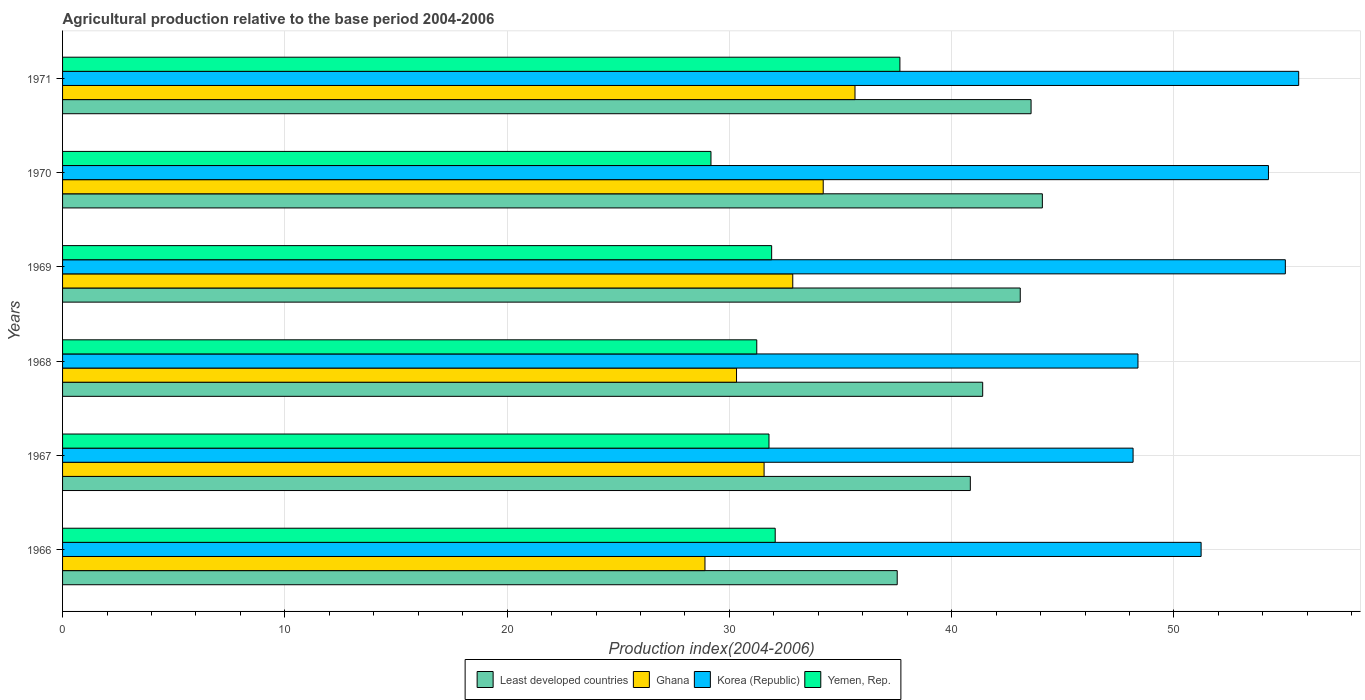How many different coloured bars are there?
Give a very brief answer. 4. Are the number of bars on each tick of the Y-axis equal?
Offer a terse response. Yes. How many bars are there on the 6th tick from the top?
Give a very brief answer. 4. What is the label of the 5th group of bars from the top?
Your response must be concise. 1967. In how many cases, is the number of bars for a given year not equal to the number of legend labels?
Your answer should be very brief. 0. What is the agricultural production index in Ghana in 1971?
Your answer should be compact. 35.65. Across all years, what is the maximum agricultural production index in Least developed countries?
Provide a short and direct response. 44.08. Across all years, what is the minimum agricultural production index in Ghana?
Keep it short and to the point. 28.9. In which year was the agricultural production index in Ghana minimum?
Provide a succinct answer. 1966. What is the total agricultural production index in Korea (Republic) in the graph?
Give a very brief answer. 312.63. What is the difference between the agricultural production index in Least developed countries in 1968 and that in 1971?
Offer a very short reply. -2.18. What is the difference between the agricultural production index in Ghana in 1971 and the agricultural production index in Korea (Republic) in 1968?
Your response must be concise. -12.73. What is the average agricultural production index in Korea (Republic) per year?
Provide a succinct answer. 52.1. In the year 1970, what is the difference between the agricultural production index in Yemen, Rep. and agricultural production index in Korea (Republic)?
Provide a short and direct response. -25.08. In how many years, is the agricultural production index in Korea (Republic) greater than 18 ?
Your answer should be very brief. 6. What is the ratio of the agricultural production index in Korea (Republic) in 1968 to that in 1970?
Provide a short and direct response. 0.89. Is the agricultural production index in Korea (Republic) in 1967 less than that in 1970?
Your answer should be compact. Yes. Is the difference between the agricultural production index in Yemen, Rep. in 1966 and 1970 greater than the difference between the agricultural production index in Korea (Republic) in 1966 and 1970?
Provide a short and direct response. Yes. What is the difference between the highest and the second highest agricultural production index in Yemen, Rep.?
Your answer should be very brief. 5.61. What is the difference between the highest and the lowest agricultural production index in Least developed countries?
Your answer should be very brief. 6.53. In how many years, is the agricultural production index in Korea (Republic) greater than the average agricultural production index in Korea (Republic) taken over all years?
Give a very brief answer. 3. Is it the case that in every year, the sum of the agricultural production index in Least developed countries and agricultural production index in Yemen, Rep. is greater than the agricultural production index in Korea (Republic)?
Make the answer very short. Yes. Are the values on the major ticks of X-axis written in scientific E-notation?
Offer a very short reply. No. Does the graph contain any zero values?
Ensure brevity in your answer.  No. Does the graph contain grids?
Make the answer very short. Yes. Where does the legend appear in the graph?
Offer a very short reply. Bottom center. How many legend labels are there?
Provide a short and direct response. 4. How are the legend labels stacked?
Your response must be concise. Horizontal. What is the title of the graph?
Your response must be concise. Agricultural production relative to the base period 2004-2006. What is the label or title of the X-axis?
Your response must be concise. Production index(2004-2006). What is the Production index(2004-2006) in Least developed countries in 1966?
Keep it short and to the point. 37.55. What is the Production index(2004-2006) in Ghana in 1966?
Offer a very short reply. 28.9. What is the Production index(2004-2006) in Korea (Republic) in 1966?
Make the answer very short. 51.22. What is the Production index(2004-2006) of Yemen, Rep. in 1966?
Provide a succinct answer. 32.06. What is the Production index(2004-2006) in Least developed countries in 1967?
Make the answer very short. 40.84. What is the Production index(2004-2006) in Ghana in 1967?
Give a very brief answer. 31.56. What is the Production index(2004-2006) in Korea (Republic) in 1967?
Offer a very short reply. 48.16. What is the Production index(2004-2006) in Yemen, Rep. in 1967?
Give a very brief answer. 31.78. What is the Production index(2004-2006) of Least developed countries in 1968?
Give a very brief answer. 41.39. What is the Production index(2004-2006) of Ghana in 1968?
Your answer should be very brief. 30.32. What is the Production index(2004-2006) of Korea (Republic) in 1968?
Your answer should be very brief. 48.38. What is the Production index(2004-2006) in Yemen, Rep. in 1968?
Provide a short and direct response. 31.23. What is the Production index(2004-2006) of Least developed countries in 1969?
Offer a terse response. 43.08. What is the Production index(2004-2006) of Ghana in 1969?
Provide a succinct answer. 32.85. What is the Production index(2004-2006) of Korea (Republic) in 1969?
Make the answer very short. 55.01. What is the Production index(2004-2006) of Yemen, Rep. in 1969?
Provide a short and direct response. 31.9. What is the Production index(2004-2006) of Least developed countries in 1970?
Offer a very short reply. 44.08. What is the Production index(2004-2006) of Ghana in 1970?
Provide a succinct answer. 34.22. What is the Production index(2004-2006) in Korea (Republic) in 1970?
Ensure brevity in your answer.  54.25. What is the Production index(2004-2006) in Yemen, Rep. in 1970?
Your answer should be very brief. 29.17. What is the Production index(2004-2006) of Least developed countries in 1971?
Make the answer very short. 43.57. What is the Production index(2004-2006) of Ghana in 1971?
Provide a short and direct response. 35.65. What is the Production index(2004-2006) in Korea (Republic) in 1971?
Ensure brevity in your answer.  55.61. What is the Production index(2004-2006) in Yemen, Rep. in 1971?
Keep it short and to the point. 37.67. Across all years, what is the maximum Production index(2004-2006) in Least developed countries?
Your response must be concise. 44.08. Across all years, what is the maximum Production index(2004-2006) of Ghana?
Offer a very short reply. 35.65. Across all years, what is the maximum Production index(2004-2006) in Korea (Republic)?
Give a very brief answer. 55.61. Across all years, what is the maximum Production index(2004-2006) of Yemen, Rep.?
Your answer should be very brief. 37.67. Across all years, what is the minimum Production index(2004-2006) in Least developed countries?
Make the answer very short. 37.55. Across all years, what is the minimum Production index(2004-2006) of Ghana?
Make the answer very short. 28.9. Across all years, what is the minimum Production index(2004-2006) of Korea (Republic)?
Your answer should be very brief. 48.16. Across all years, what is the minimum Production index(2004-2006) of Yemen, Rep.?
Offer a very short reply. 29.17. What is the total Production index(2004-2006) of Least developed countries in the graph?
Provide a short and direct response. 250.51. What is the total Production index(2004-2006) in Ghana in the graph?
Your response must be concise. 193.5. What is the total Production index(2004-2006) in Korea (Republic) in the graph?
Your answer should be very brief. 312.63. What is the total Production index(2004-2006) in Yemen, Rep. in the graph?
Offer a terse response. 193.81. What is the difference between the Production index(2004-2006) in Least developed countries in 1966 and that in 1967?
Give a very brief answer. -3.29. What is the difference between the Production index(2004-2006) in Ghana in 1966 and that in 1967?
Keep it short and to the point. -2.66. What is the difference between the Production index(2004-2006) in Korea (Republic) in 1966 and that in 1967?
Ensure brevity in your answer.  3.06. What is the difference between the Production index(2004-2006) in Yemen, Rep. in 1966 and that in 1967?
Provide a short and direct response. 0.28. What is the difference between the Production index(2004-2006) in Least developed countries in 1966 and that in 1968?
Give a very brief answer. -3.85. What is the difference between the Production index(2004-2006) in Ghana in 1966 and that in 1968?
Ensure brevity in your answer.  -1.42. What is the difference between the Production index(2004-2006) of Korea (Republic) in 1966 and that in 1968?
Provide a short and direct response. 2.84. What is the difference between the Production index(2004-2006) of Yemen, Rep. in 1966 and that in 1968?
Your answer should be very brief. 0.83. What is the difference between the Production index(2004-2006) in Least developed countries in 1966 and that in 1969?
Keep it short and to the point. -5.53. What is the difference between the Production index(2004-2006) of Ghana in 1966 and that in 1969?
Your response must be concise. -3.95. What is the difference between the Production index(2004-2006) in Korea (Republic) in 1966 and that in 1969?
Offer a very short reply. -3.79. What is the difference between the Production index(2004-2006) of Yemen, Rep. in 1966 and that in 1969?
Make the answer very short. 0.16. What is the difference between the Production index(2004-2006) in Least developed countries in 1966 and that in 1970?
Ensure brevity in your answer.  -6.53. What is the difference between the Production index(2004-2006) of Ghana in 1966 and that in 1970?
Ensure brevity in your answer.  -5.32. What is the difference between the Production index(2004-2006) in Korea (Republic) in 1966 and that in 1970?
Your response must be concise. -3.03. What is the difference between the Production index(2004-2006) of Yemen, Rep. in 1966 and that in 1970?
Your answer should be compact. 2.89. What is the difference between the Production index(2004-2006) in Least developed countries in 1966 and that in 1971?
Provide a short and direct response. -6.02. What is the difference between the Production index(2004-2006) of Ghana in 1966 and that in 1971?
Give a very brief answer. -6.75. What is the difference between the Production index(2004-2006) of Korea (Republic) in 1966 and that in 1971?
Make the answer very short. -4.39. What is the difference between the Production index(2004-2006) of Yemen, Rep. in 1966 and that in 1971?
Offer a very short reply. -5.61. What is the difference between the Production index(2004-2006) of Least developed countries in 1967 and that in 1968?
Give a very brief answer. -0.56. What is the difference between the Production index(2004-2006) in Ghana in 1967 and that in 1968?
Your answer should be compact. 1.24. What is the difference between the Production index(2004-2006) in Korea (Republic) in 1967 and that in 1968?
Offer a terse response. -0.22. What is the difference between the Production index(2004-2006) in Yemen, Rep. in 1967 and that in 1968?
Provide a succinct answer. 0.55. What is the difference between the Production index(2004-2006) in Least developed countries in 1967 and that in 1969?
Make the answer very short. -2.25. What is the difference between the Production index(2004-2006) of Ghana in 1967 and that in 1969?
Offer a very short reply. -1.29. What is the difference between the Production index(2004-2006) in Korea (Republic) in 1967 and that in 1969?
Make the answer very short. -6.85. What is the difference between the Production index(2004-2006) of Yemen, Rep. in 1967 and that in 1969?
Give a very brief answer. -0.12. What is the difference between the Production index(2004-2006) of Least developed countries in 1967 and that in 1970?
Make the answer very short. -3.24. What is the difference between the Production index(2004-2006) in Ghana in 1967 and that in 1970?
Your answer should be compact. -2.66. What is the difference between the Production index(2004-2006) of Korea (Republic) in 1967 and that in 1970?
Ensure brevity in your answer.  -6.09. What is the difference between the Production index(2004-2006) of Yemen, Rep. in 1967 and that in 1970?
Offer a terse response. 2.61. What is the difference between the Production index(2004-2006) in Least developed countries in 1967 and that in 1971?
Provide a short and direct response. -2.73. What is the difference between the Production index(2004-2006) in Ghana in 1967 and that in 1971?
Your answer should be compact. -4.09. What is the difference between the Production index(2004-2006) in Korea (Republic) in 1967 and that in 1971?
Give a very brief answer. -7.45. What is the difference between the Production index(2004-2006) of Yemen, Rep. in 1967 and that in 1971?
Make the answer very short. -5.89. What is the difference between the Production index(2004-2006) of Least developed countries in 1968 and that in 1969?
Give a very brief answer. -1.69. What is the difference between the Production index(2004-2006) of Ghana in 1968 and that in 1969?
Keep it short and to the point. -2.53. What is the difference between the Production index(2004-2006) in Korea (Republic) in 1968 and that in 1969?
Your answer should be compact. -6.63. What is the difference between the Production index(2004-2006) in Yemen, Rep. in 1968 and that in 1969?
Provide a succinct answer. -0.67. What is the difference between the Production index(2004-2006) in Least developed countries in 1968 and that in 1970?
Give a very brief answer. -2.68. What is the difference between the Production index(2004-2006) in Korea (Republic) in 1968 and that in 1970?
Provide a short and direct response. -5.87. What is the difference between the Production index(2004-2006) in Yemen, Rep. in 1968 and that in 1970?
Keep it short and to the point. 2.06. What is the difference between the Production index(2004-2006) of Least developed countries in 1968 and that in 1971?
Keep it short and to the point. -2.18. What is the difference between the Production index(2004-2006) in Ghana in 1968 and that in 1971?
Provide a short and direct response. -5.33. What is the difference between the Production index(2004-2006) in Korea (Republic) in 1968 and that in 1971?
Your answer should be compact. -7.23. What is the difference between the Production index(2004-2006) of Yemen, Rep. in 1968 and that in 1971?
Your answer should be compact. -6.44. What is the difference between the Production index(2004-2006) of Least developed countries in 1969 and that in 1970?
Offer a terse response. -0.99. What is the difference between the Production index(2004-2006) of Ghana in 1969 and that in 1970?
Keep it short and to the point. -1.37. What is the difference between the Production index(2004-2006) in Korea (Republic) in 1969 and that in 1970?
Provide a succinct answer. 0.76. What is the difference between the Production index(2004-2006) of Yemen, Rep. in 1969 and that in 1970?
Ensure brevity in your answer.  2.73. What is the difference between the Production index(2004-2006) of Least developed countries in 1969 and that in 1971?
Offer a very short reply. -0.49. What is the difference between the Production index(2004-2006) in Yemen, Rep. in 1969 and that in 1971?
Offer a very short reply. -5.77. What is the difference between the Production index(2004-2006) in Least developed countries in 1970 and that in 1971?
Your answer should be compact. 0.51. What is the difference between the Production index(2004-2006) in Ghana in 1970 and that in 1971?
Offer a very short reply. -1.43. What is the difference between the Production index(2004-2006) in Korea (Republic) in 1970 and that in 1971?
Offer a terse response. -1.36. What is the difference between the Production index(2004-2006) in Least developed countries in 1966 and the Production index(2004-2006) in Ghana in 1967?
Offer a very short reply. 5.99. What is the difference between the Production index(2004-2006) in Least developed countries in 1966 and the Production index(2004-2006) in Korea (Republic) in 1967?
Keep it short and to the point. -10.61. What is the difference between the Production index(2004-2006) in Least developed countries in 1966 and the Production index(2004-2006) in Yemen, Rep. in 1967?
Make the answer very short. 5.77. What is the difference between the Production index(2004-2006) of Ghana in 1966 and the Production index(2004-2006) of Korea (Republic) in 1967?
Give a very brief answer. -19.26. What is the difference between the Production index(2004-2006) of Ghana in 1966 and the Production index(2004-2006) of Yemen, Rep. in 1967?
Offer a terse response. -2.88. What is the difference between the Production index(2004-2006) in Korea (Republic) in 1966 and the Production index(2004-2006) in Yemen, Rep. in 1967?
Your answer should be very brief. 19.44. What is the difference between the Production index(2004-2006) of Least developed countries in 1966 and the Production index(2004-2006) of Ghana in 1968?
Offer a very short reply. 7.23. What is the difference between the Production index(2004-2006) of Least developed countries in 1966 and the Production index(2004-2006) of Korea (Republic) in 1968?
Offer a very short reply. -10.83. What is the difference between the Production index(2004-2006) of Least developed countries in 1966 and the Production index(2004-2006) of Yemen, Rep. in 1968?
Ensure brevity in your answer.  6.32. What is the difference between the Production index(2004-2006) in Ghana in 1966 and the Production index(2004-2006) in Korea (Republic) in 1968?
Offer a terse response. -19.48. What is the difference between the Production index(2004-2006) of Ghana in 1966 and the Production index(2004-2006) of Yemen, Rep. in 1968?
Give a very brief answer. -2.33. What is the difference between the Production index(2004-2006) in Korea (Republic) in 1966 and the Production index(2004-2006) in Yemen, Rep. in 1968?
Provide a short and direct response. 19.99. What is the difference between the Production index(2004-2006) of Least developed countries in 1966 and the Production index(2004-2006) of Ghana in 1969?
Your response must be concise. 4.7. What is the difference between the Production index(2004-2006) in Least developed countries in 1966 and the Production index(2004-2006) in Korea (Republic) in 1969?
Keep it short and to the point. -17.46. What is the difference between the Production index(2004-2006) of Least developed countries in 1966 and the Production index(2004-2006) of Yemen, Rep. in 1969?
Your answer should be compact. 5.65. What is the difference between the Production index(2004-2006) in Ghana in 1966 and the Production index(2004-2006) in Korea (Republic) in 1969?
Keep it short and to the point. -26.11. What is the difference between the Production index(2004-2006) of Korea (Republic) in 1966 and the Production index(2004-2006) of Yemen, Rep. in 1969?
Ensure brevity in your answer.  19.32. What is the difference between the Production index(2004-2006) of Least developed countries in 1966 and the Production index(2004-2006) of Ghana in 1970?
Provide a short and direct response. 3.33. What is the difference between the Production index(2004-2006) of Least developed countries in 1966 and the Production index(2004-2006) of Korea (Republic) in 1970?
Ensure brevity in your answer.  -16.7. What is the difference between the Production index(2004-2006) in Least developed countries in 1966 and the Production index(2004-2006) in Yemen, Rep. in 1970?
Provide a succinct answer. 8.38. What is the difference between the Production index(2004-2006) in Ghana in 1966 and the Production index(2004-2006) in Korea (Republic) in 1970?
Ensure brevity in your answer.  -25.35. What is the difference between the Production index(2004-2006) of Ghana in 1966 and the Production index(2004-2006) of Yemen, Rep. in 1970?
Ensure brevity in your answer.  -0.27. What is the difference between the Production index(2004-2006) of Korea (Republic) in 1966 and the Production index(2004-2006) of Yemen, Rep. in 1970?
Ensure brevity in your answer.  22.05. What is the difference between the Production index(2004-2006) in Least developed countries in 1966 and the Production index(2004-2006) in Ghana in 1971?
Make the answer very short. 1.9. What is the difference between the Production index(2004-2006) of Least developed countries in 1966 and the Production index(2004-2006) of Korea (Republic) in 1971?
Your answer should be very brief. -18.06. What is the difference between the Production index(2004-2006) in Least developed countries in 1966 and the Production index(2004-2006) in Yemen, Rep. in 1971?
Make the answer very short. -0.12. What is the difference between the Production index(2004-2006) of Ghana in 1966 and the Production index(2004-2006) of Korea (Republic) in 1971?
Make the answer very short. -26.71. What is the difference between the Production index(2004-2006) in Ghana in 1966 and the Production index(2004-2006) in Yemen, Rep. in 1971?
Provide a succinct answer. -8.77. What is the difference between the Production index(2004-2006) of Korea (Republic) in 1966 and the Production index(2004-2006) of Yemen, Rep. in 1971?
Provide a short and direct response. 13.55. What is the difference between the Production index(2004-2006) in Least developed countries in 1967 and the Production index(2004-2006) in Ghana in 1968?
Ensure brevity in your answer.  10.52. What is the difference between the Production index(2004-2006) of Least developed countries in 1967 and the Production index(2004-2006) of Korea (Republic) in 1968?
Give a very brief answer. -7.54. What is the difference between the Production index(2004-2006) in Least developed countries in 1967 and the Production index(2004-2006) in Yemen, Rep. in 1968?
Keep it short and to the point. 9.61. What is the difference between the Production index(2004-2006) in Ghana in 1967 and the Production index(2004-2006) in Korea (Republic) in 1968?
Offer a terse response. -16.82. What is the difference between the Production index(2004-2006) of Ghana in 1967 and the Production index(2004-2006) of Yemen, Rep. in 1968?
Ensure brevity in your answer.  0.33. What is the difference between the Production index(2004-2006) of Korea (Republic) in 1967 and the Production index(2004-2006) of Yemen, Rep. in 1968?
Your response must be concise. 16.93. What is the difference between the Production index(2004-2006) of Least developed countries in 1967 and the Production index(2004-2006) of Ghana in 1969?
Ensure brevity in your answer.  7.99. What is the difference between the Production index(2004-2006) in Least developed countries in 1967 and the Production index(2004-2006) in Korea (Republic) in 1969?
Provide a short and direct response. -14.17. What is the difference between the Production index(2004-2006) of Least developed countries in 1967 and the Production index(2004-2006) of Yemen, Rep. in 1969?
Provide a short and direct response. 8.94. What is the difference between the Production index(2004-2006) in Ghana in 1967 and the Production index(2004-2006) in Korea (Republic) in 1969?
Offer a terse response. -23.45. What is the difference between the Production index(2004-2006) of Ghana in 1967 and the Production index(2004-2006) of Yemen, Rep. in 1969?
Your response must be concise. -0.34. What is the difference between the Production index(2004-2006) of Korea (Republic) in 1967 and the Production index(2004-2006) of Yemen, Rep. in 1969?
Provide a short and direct response. 16.26. What is the difference between the Production index(2004-2006) of Least developed countries in 1967 and the Production index(2004-2006) of Ghana in 1970?
Ensure brevity in your answer.  6.62. What is the difference between the Production index(2004-2006) in Least developed countries in 1967 and the Production index(2004-2006) in Korea (Republic) in 1970?
Your response must be concise. -13.41. What is the difference between the Production index(2004-2006) of Least developed countries in 1967 and the Production index(2004-2006) of Yemen, Rep. in 1970?
Make the answer very short. 11.67. What is the difference between the Production index(2004-2006) in Ghana in 1967 and the Production index(2004-2006) in Korea (Republic) in 1970?
Ensure brevity in your answer.  -22.69. What is the difference between the Production index(2004-2006) of Ghana in 1967 and the Production index(2004-2006) of Yemen, Rep. in 1970?
Your response must be concise. 2.39. What is the difference between the Production index(2004-2006) of Korea (Republic) in 1967 and the Production index(2004-2006) of Yemen, Rep. in 1970?
Your response must be concise. 18.99. What is the difference between the Production index(2004-2006) in Least developed countries in 1967 and the Production index(2004-2006) in Ghana in 1971?
Your answer should be very brief. 5.19. What is the difference between the Production index(2004-2006) of Least developed countries in 1967 and the Production index(2004-2006) of Korea (Republic) in 1971?
Your response must be concise. -14.77. What is the difference between the Production index(2004-2006) of Least developed countries in 1967 and the Production index(2004-2006) of Yemen, Rep. in 1971?
Your response must be concise. 3.17. What is the difference between the Production index(2004-2006) of Ghana in 1967 and the Production index(2004-2006) of Korea (Republic) in 1971?
Offer a very short reply. -24.05. What is the difference between the Production index(2004-2006) of Ghana in 1967 and the Production index(2004-2006) of Yemen, Rep. in 1971?
Offer a very short reply. -6.11. What is the difference between the Production index(2004-2006) in Korea (Republic) in 1967 and the Production index(2004-2006) in Yemen, Rep. in 1971?
Offer a very short reply. 10.49. What is the difference between the Production index(2004-2006) in Least developed countries in 1968 and the Production index(2004-2006) in Ghana in 1969?
Give a very brief answer. 8.54. What is the difference between the Production index(2004-2006) in Least developed countries in 1968 and the Production index(2004-2006) in Korea (Republic) in 1969?
Your answer should be compact. -13.62. What is the difference between the Production index(2004-2006) of Least developed countries in 1968 and the Production index(2004-2006) of Yemen, Rep. in 1969?
Make the answer very short. 9.49. What is the difference between the Production index(2004-2006) in Ghana in 1968 and the Production index(2004-2006) in Korea (Republic) in 1969?
Keep it short and to the point. -24.69. What is the difference between the Production index(2004-2006) of Ghana in 1968 and the Production index(2004-2006) of Yemen, Rep. in 1969?
Give a very brief answer. -1.58. What is the difference between the Production index(2004-2006) in Korea (Republic) in 1968 and the Production index(2004-2006) in Yemen, Rep. in 1969?
Offer a very short reply. 16.48. What is the difference between the Production index(2004-2006) of Least developed countries in 1968 and the Production index(2004-2006) of Ghana in 1970?
Ensure brevity in your answer.  7.17. What is the difference between the Production index(2004-2006) of Least developed countries in 1968 and the Production index(2004-2006) of Korea (Republic) in 1970?
Provide a succinct answer. -12.86. What is the difference between the Production index(2004-2006) of Least developed countries in 1968 and the Production index(2004-2006) of Yemen, Rep. in 1970?
Your answer should be compact. 12.22. What is the difference between the Production index(2004-2006) of Ghana in 1968 and the Production index(2004-2006) of Korea (Republic) in 1970?
Make the answer very short. -23.93. What is the difference between the Production index(2004-2006) of Ghana in 1968 and the Production index(2004-2006) of Yemen, Rep. in 1970?
Make the answer very short. 1.15. What is the difference between the Production index(2004-2006) in Korea (Republic) in 1968 and the Production index(2004-2006) in Yemen, Rep. in 1970?
Make the answer very short. 19.21. What is the difference between the Production index(2004-2006) in Least developed countries in 1968 and the Production index(2004-2006) in Ghana in 1971?
Ensure brevity in your answer.  5.74. What is the difference between the Production index(2004-2006) in Least developed countries in 1968 and the Production index(2004-2006) in Korea (Republic) in 1971?
Your answer should be very brief. -14.22. What is the difference between the Production index(2004-2006) in Least developed countries in 1968 and the Production index(2004-2006) in Yemen, Rep. in 1971?
Offer a terse response. 3.72. What is the difference between the Production index(2004-2006) of Ghana in 1968 and the Production index(2004-2006) of Korea (Republic) in 1971?
Give a very brief answer. -25.29. What is the difference between the Production index(2004-2006) of Ghana in 1968 and the Production index(2004-2006) of Yemen, Rep. in 1971?
Offer a very short reply. -7.35. What is the difference between the Production index(2004-2006) of Korea (Republic) in 1968 and the Production index(2004-2006) of Yemen, Rep. in 1971?
Your response must be concise. 10.71. What is the difference between the Production index(2004-2006) in Least developed countries in 1969 and the Production index(2004-2006) in Ghana in 1970?
Give a very brief answer. 8.86. What is the difference between the Production index(2004-2006) of Least developed countries in 1969 and the Production index(2004-2006) of Korea (Republic) in 1970?
Offer a terse response. -11.17. What is the difference between the Production index(2004-2006) in Least developed countries in 1969 and the Production index(2004-2006) in Yemen, Rep. in 1970?
Make the answer very short. 13.91. What is the difference between the Production index(2004-2006) of Ghana in 1969 and the Production index(2004-2006) of Korea (Republic) in 1970?
Your answer should be very brief. -21.4. What is the difference between the Production index(2004-2006) in Ghana in 1969 and the Production index(2004-2006) in Yemen, Rep. in 1970?
Make the answer very short. 3.68. What is the difference between the Production index(2004-2006) of Korea (Republic) in 1969 and the Production index(2004-2006) of Yemen, Rep. in 1970?
Offer a terse response. 25.84. What is the difference between the Production index(2004-2006) of Least developed countries in 1969 and the Production index(2004-2006) of Ghana in 1971?
Make the answer very short. 7.43. What is the difference between the Production index(2004-2006) in Least developed countries in 1969 and the Production index(2004-2006) in Korea (Republic) in 1971?
Ensure brevity in your answer.  -12.53. What is the difference between the Production index(2004-2006) in Least developed countries in 1969 and the Production index(2004-2006) in Yemen, Rep. in 1971?
Keep it short and to the point. 5.41. What is the difference between the Production index(2004-2006) in Ghana in 1969 and the Production index(2004-2006) in Korea (Republic) in 1971?
Keep it short and to the point. -22.76. What is the difference between the Production index(2004-2006) of Ghana in 1969 and the Production index(2004-2006) of Yemen, Rep. in 1971?
Your answer should be very brief. -4.82. What is the difference between the Production index(2004-2006) in Korea (Republic) in 1969 and the Production index(2004-2006) in Yemen, Rep. in 1971?
Your answer should be very brief. 17.34. What is the difference between the Production index(2004-2006) of Least developed countries in 1970 and the Production index(2004-2006) of Ghana in 1971?
Your answer should be very brief. 8.43. What is the difference between the Production index(2004-2006) in Least developed countries in 1970 and the Production index(2004-2006) in Korea (Republic) in 1971?
Offer a very short reply. -11.53. What is the difference between the Production index(2004-2006) of Least developed countries in 1970 and the Production index(2004-2006) of Yemen, Rep. in 1971?
Keep it short and to the point. 6.41. What is the difference between the Production index(2004-2006) in Ghana in 1970 and the Production index(2004-2006) in Korea (Republic) in 1971?
Keep it short and to the point. -21.39. What is the difference between the Production index(2004-2006) of Ghana in 1970 and the Production index(2004-2006) of Yemen, Rep. in 1971?
Ensure brevity in your answer.  -3.45. What is the difference between the Production index(2004-2006) in Korea (Republic) in 1970 and the Production index(2004-2006) in Yemen, Rep. in 1971?
Give a very brief answer. 16.58. What is the average Production index(2004-2006) in Least developed countries per year?
Your answer should be compact. 41.75. What is the average Production index(2004-2006) in Ghana per year?
Offer a very short reply. 32.25. What is the average Production index(2004-2006) in Korea (Republic) per year?
Give a very brief answer. 52.1. What is the average Production index(2004-2006) of Yemen, Rep. per year?
Provide a short and direct response. 32.3. In the year 1966, what is the difference between the Production index(2004-2006) in Least developed countries and Production index(2004-2006) in Ghana?
Offer a terse response. 8.65. In the year 1966, what is the difference between the Production index(2004-2006) of Least developed countries and Production index(2004-2006) of Korea (Republic)?
Your answer should be very brief. -13.67. In the year 1966, what is the difference between the Production index(2004-2006) of Least developed countries and Production index(2004-2006) of Yemen, Rep.?
Your answer should be very brief. 5.49. In the year 1966, what is the difference between the Production index(2004-2006) of Ghana and Production index(2004-2006) of Korea (Republic)?
Your response must be concise. -22.32. In the year 1966, what is the difference between the Production index(2004-2006) in Ghana and Production index(2004-2006) in Yemen, Rep.?
Ensure brevity in your answer.  -3.16. In the year 1966, what is the difference between the Production index(2004-2006) of Korea (Republic) and Production index(2004-2006) of Yemen, Rep.?
Your response must be concise. 19.16. In the year 1967, what is the difference between the Production index(2004-2006) in Least developed countries and Production index(2004-2006) in Ghana?
Offer a very short reply. 9.28. In the year 1967, what is the difference between the Production index(2004-2006) of Least developed countries and Production index(2004-2006) of Korea (Republic)?
Offer a terse response. -7.32. In the year 1967, what is the difference between the Production index(2004-2006) in Least developed countries and Production index(2004-2006) in Yemen, Rep.?
Offer a very short reply. 9.06. In the year 1967, what is the difference between the Production index(2004-2006) in Ghana and Production index(2004-2006) in Korea (Republic)?
Ensure brevity in your answer.  -16.6. In the year 1967, what is the difference between the Production index(2004-2006) in Ghana and Production index(2004-2006) in Yemen, Rep.?
Provide a short and direct response. -0.22. In the year 1967, what is the difference between the Production index(2004-2006) in Korea (Republic) and Production index(2004-2006) in Yemen, Rep.?
Offer a very short reply. 16.38. In the year 1968, what is the difference between the Production index(2004-2006) in Least developed countries and Production index(2004-2006) in Ghana?
Offer a very short reply. 11.07. In the year 1968, what is the difference between the Production index(2004-2006) of Least developed countries and Production index(2004-2006) of Korea (Republic)?
Ensure brevity in your answer.  -6.99. In the year 1968, what is the difference between the Production index(2004-2006) in Least developed countries and Production index(2004-2006) in Yemen, Rep.?
Your answer should be compact. 10.16. In the year 1968, what is the difference between the Production index(2004-2006) in Ghana and Production index(2004-2006) in Korea (Republic)?
Provide a succinct answer. -18.06. In the year 1968, what is the difference between the Production index(2004-2006) in Ghana and Production index(2004-2006) in Yemen, Rep.?
Make the answer very short. -0.91. In the year 1968, what is the difference between the Production index(2004-2006) in Korea (Republic) and Production index(2004-2006) in Yemen, Rep.?
Make the answer very short. 17.15. In the year 1969, what is the difference between the Production index(2004-2006) in Least developed countries and Production index(2004-2006) in Ghana?
Your response must be concise. 10.23. In the year 1969, what is the difference between the Production index(2004-2006) of Least developed countries and Production index(2004-2006) of Korea (Republic)?
Provide a succinct answer. -11.93. In the year 1969, what is the difference between the Production index(2004-2006) in Least developed countries and Production index(2004-2006) in Yemen, Rep.?
Offer a terse response. 11.18. In the year 1969, what is the difference between the Production index(2004-2006) in Ghana and Production index(2004-2006) in Korea (Republic)?
Offer a terse response. -22.16. In the year 1969, what is the difference between the Production index(2004-2006) in Ghana and Production index(2004-2006) in Yemen, Rep.?
Make the answer very short. 0.95. In the year 1969, what is the difference between the Production index(2004-2006) in Korea (Republic) and Production index(2004-2006) in Yemen, Rep.?
Offer a terse response. 23.11. In the year 1970, what is the difference between the Production index(2004-2006) of Least developed countries and Production index(2004-2006) of Ghana?
Provide a short and direct response. 9.86. In the year 1970, what is the difference between the Production index(2004-2006) of Least developed countries and Production index(2004-2006) of Korea (Republic)?
Your answer should be very brief. -10.17. In the year 1970, what is the difference between the Production index(2004-2006) of Least developed countries and Production index(2004-2006) of Yemen, Rep.?
Provide a succinct answer. 14.91. In the year 1970, what is the difference between the Production index(2004-2006) of Ghana and Production index(2004-2006) of Korea (Republic)?
Make the answer very short. -20.03. In the year 1970, what is the difference between the Production index(2004-2006) of Ghana and Production index(2004-2006) of Yemen, Rep.?
Your answer should be very brief. 5.05. In the year 1970, what is the difference between the Production index(2004-2006) of Korea (Republic) and Production index(2004-2006) of Yemen, Rep.?
Provide a succinct answer. 25.08. In the year 1971, what is the difference between the Production index(2004-2006) of Least developed countries and Production index(2004-2006) of Ghana?
Offer a very short reply. 7.92. In the year 1971, what is the difference between the Production index(2004-2006) in Least developed countries and Production index(2004-2006) in Korea (Republic)?
Offer a terse response. -12.04. In the year 1971, what is the difference between the Production index(2004-2006) in Least developed countries and Production index(2004-2006) in Yemen, Rep.?
Your answer should be very brief. 5.9. In the year 1971, what is the difference between the Production index(2004-2006) of Ghana and Production index(2004-2006) of Korea (Republic)?
Keep it short and to the point. -19.96. In the year 1971, what is the difference between the Production index(2004-2006) in Ghana and Production index(2004-2006) in Yemen, Rep.?
Offer a terse response. -2.02. In the year 1971, what is the difference between the Production index(2004-2006) in Korea (Republic) and Production index(2004-2006) in Yemen, Rep.?
Make the answer very short. 17.94. What is the ratio of the Production index(2004-2006) of Least developed countries in 1966 to that in 1967?
Provide a succinct answer. 0.92. What is the ratio of the Production index(2004-2006) of Ghana in 1966 to that in 1967?
Give a very brief answer. 0.92. What is the ratio of the Production index(2004-2006) in Korea (Republic) in 1966 to that in 1967?
Your answer should be very brief. 1.06. What is the ratio of the Production index(2004-2006) in Yemen, Rep. in 1966 to that in 1967?
Offer a very short reply. 1.01. What is the ratio of the Production index(2004-2006) in Least developed countries in 1966 to that in 1968?
Make the answer very short. 0.91. What is the ratio of the Production index(2004-2006) of Ghana in 1966 to that in 1968?
Keep it short and to the point. 0.95. What is the ratio of the Production index(2004-2006) of Korea (Republic) in 1966 to that in 1968?
Your answer should be compact. 1.06. What is the ratio of the Production index(2004-2006) of Yemen, Rep. in 1966 to that in 1968?
Ensure brevity in your answer.  1.03. What is the ratio of the Production index(2004-2006) in Least developed countries in 1966 to that in 1969?
Offer a terse response. 0.87. What is the ratio of the Production index(2004-2006) in Ghana in 1966 to that in 1969?
Offer a terse response. 0.88. What is the ratio of the Production index(2004-2006) in Korea (Republic) in 1966 to that in 1969?
Provide a short and direct response. 0.93. What is the ratio of the Production index(2004-2006) in Least developed countries in 1966 to that in 1970?
Your answer should be very brief. 0.85. What is the ratio of the Production index(2004-2006) in Ghana in 1966 to that in 1970?
Give a very brief answer. 0.84. What is the ratio of the Production index(2004-2006) in Korea (Republic) in 1966 to that in 1970?
Provide a succinct answer. 0.94. What is the ratio of the Production index(2004-2006) of Yemen, Rep. in 1966 to that in 1970?
Provide a short and direct response. 1.1. What is the ratio of the Production index(2004-2006) of Least developed countries in 1966 to that in 1971?
Your answer should be compact. 0.86. What is the ratio of the Production index(2004-2006) in Ghana in 1966 to that in 1971?
Ensure brevity in your answer.  0.81. What is the ratio of the Production index(2004-2006) in Korea (Republic) in 1966 to that in 1971?
Make the answer very short. 0.92. What is the ratio of the Production index(2004-2006) in Yemen, Rep. in 1966 to that in 1971?
Provide a succinct answer. 0.85. What is the ratio of the Production index(2004-2006) in Least developed countries in 1967 to that in 1968?
Make the answer very short. 0.99. What is the ratio of the Production index(2004-2006) of Ghana in 1967 to that in 1968?
Your answer should be compact. 1.04. What is the ratio of the Production index(2004-2006) of Korea (Republic) in 1967 to that in 1968?
Ensure brevity in your answer.  1. What is the ratio of the Production index(2004-2006) of Yemen, Rep. in 1967 to that in 1968?
Your answer should be compact. 1.02. What is the ratio of the Production index(2004-2006) in Least developed countries in 1967 to that in 1969?
Provide a short and direct response. 0.95. What is the ratio of the Production index(2004-2006) in Ghana in 1967 to that in 1969?
Offer a terse response. 0.96. What is the ratio of the Production index(2004-2006) of Korea (Republic) in 1967 to that in 1969?
Offer a very short reply. 0.88. What is the ratio of the Production index(2004-2006) in Yemen, Rep. in 1967 to that in 1969?
Keep it short and to the point. 1. What is the ratio of the Production index(2004-2006) of Least developed countries in 1967 to that in 1970?
Ensure brevity in your answer.  0.93. What is the ratio of the Production index(2004-2006) of Ghana in 1967 to that in 1970?
Offer a very short reply. 0.92. What is the ratio of the Production index(2004-2006) of Korea (Republic) in 1967 to that in 1970?
Provide a short and direct response. 0.89. What is the ratio of the Production index(2004-2006) of Yemen, Rep. in 1967 to that in 1970?
Provide a short and direct response. 1.09. What is the ratio of the Production index(2004-2006) in Least developed countries in 1967 to that in 1971?
Make the answer very short. 0.94. What is the ratio of the Production index(2004-2006) in Ghana in 1967 to that in 1971?
Give a very brief answer. 0.89. What is the ratio of the Production index(2004-2006) of Korea (Republic) in 1967 to that in 1971?
Offer a terse response. 0.87. What is the ratio of the Production index(2004-2006) of Yemen, Rep. in 1967 to that in 1971?
Your response must be concise. 0.84. What is the ratio of the Production index(2004-2006) in Least developed countries in 1968 to that in 1969?
Give a very brief answer. 0.96. What is the ratio of the Production index(2004-2006) of Ghana in 1968 to that in 1969?
Offer a very short reply. 0.92. What is the ratio of the Production index(2004-2006) of Korea (Republic) in 1968 to that in 1969?
Provide a succinct answer. 0.88. What is the ratio of the Production index(2004-2006) in Yemen, Rep. in 1968 to that in 1969?
Make the answer very short. 0.98. What is the ratio of the Production index(2004-2006) of Least developed countries in 1968 to that in 1970?
Offer a terse response. 0.94. What is the ratio of the Production index(2004-2006) in Ghana in 1968 to that in 1970?
Your answer should be very brief. 0.89. What is the ratio of the Production index(2004-2006) in Korea (Republic) in 1968 to that in 1970?
Provide a succinct answer. 0.89. What is the ratio of the Production index(2004-2006) in Yemen, Rep. in 1968 to that in 1970?
Your answer should be compact. 1.07. What is the ratio of the Production index(2004-2006) of Ghana in 1968 to that in 1971?
Your response must be concise. 0.85. What is the ratio of the Production index(2004-2006) in Korea (Republic) in 1968 to that in 1971?
Offer a terse response. 0.87. What is the ratio of the Production index(2004-2006) of Yemen, Rep. in 1968 to that in 1971?
Provide a succinct answer. 0.83. What is the ratio of the Production index(2004-2006) in Least developed countries in 1969 to that in 1970?
Offer a terse response. 0.98. What is the ratio of the Production index(2004-2006) in Korea (Republic) in 1969 to that in 1970?
Ensure brevity in your answer.  1.01. What is the ratio of the Production index(2004-2006) of Yemen, Rep. in 1969 to that in 1970?
Your answer should be very brief. 1.09. What is the ratio of the Production index(2004-2006) in Ghana in 1969 to that in 1971?
Give a very brief answer. 0.92. What is the ratio of the Production index(2004-2006) of Yemen, Rep. in 1969 to that in 1971?
Your answer should be very brief. 0.85. What is the ratio of the Production index(2004-2006) of Least developed countries in 1970 to that in 1971?
Ensure brevity in your answer.  1.01. What is the ratio of the Production index(2004-2006) of Ghana in 1970 to that in 1971?
Offer a very short reply. 0.96. What is the ratio of the Production index(2004-2006) in Korea (Republic) in 1970 to that in 1971?
Offer a terse response. 0.98. What is the ratio of the Production index(2004-2006) in Yemen, Rep. in 1970 to that in 1971?
Your answer should be compact. 0.77. What is the difference between the highest and the second highest Production index(2004-2006) in Least developed countries?
Ensure brevity in your answer.  0.51. What is the difference between the highest and the second highest Production index(2004-2006) in Ghana?
Provide a short and direct response. 1.43. What is the difference between the highest and the second highest Production index(2004-2006) in Korea (Republic)?
Make the answer very short. 0.6. What is the difference between the highest and the second highest Production index(2004-2006) in Yemen, Rep.?
Your response must be concise. 5.61. What is the difference between the highest and the lowest Production index(2004-2006) of Least developed countries?
Ensure brevity in your answer.  6.53. What is the difference between the highest and the lowest Production index(2004-2006) of Ghana?
Provide a succinct answer. 6.75. What is the difference between the highest and the lowest Production index(2004-2006) in Korea (Republic)?
Provide a succinct answer. 7.45. 